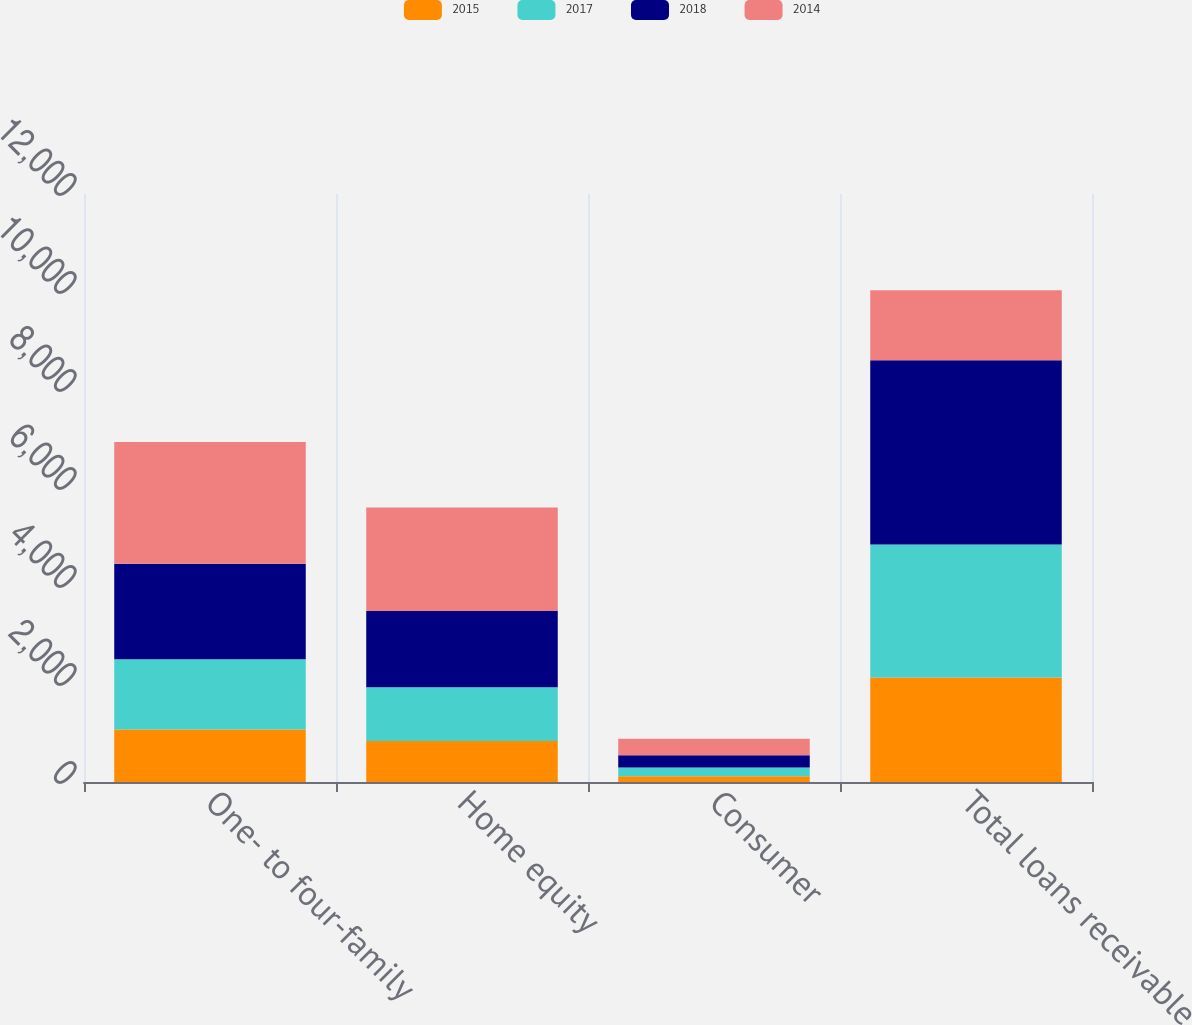Convert chart to OTSL. <chart><loc_0><loc_0><loc_500><loc_500><stacked_bar_chart><ecel><fcel>One- to four-family<fcel>Home equity<fcel>Consumer<fcel>Total loans receivable<nl><fcel>2015<fcel>1071<fcel>836<fcel>118<fcel>2132<nl><fcel>2017<fcel>1432<fcel>1097<fcel>176<fcel>2717<nl><fcel>2018<fcel>1950<fcel>1556<fcel>250<fcel>3756<nl><fcel>2014<fcel>2488<fcel>2114<fcel>341<fcel>1432<nl></chart> 